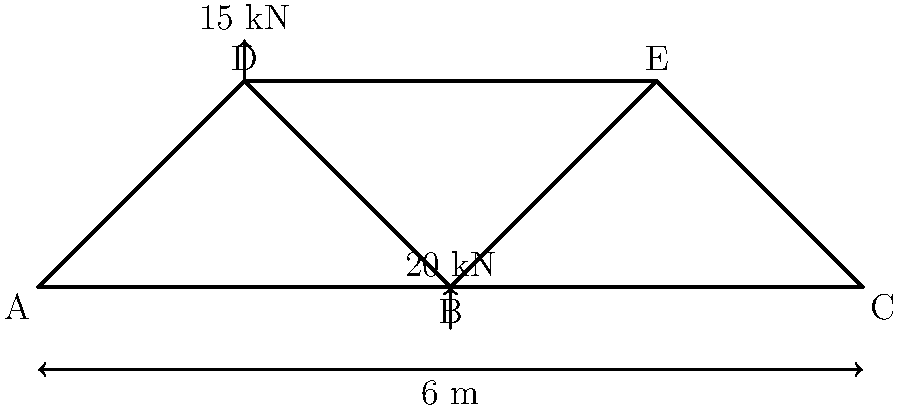As a civil engineer working on a project supported by Benjamin Kofi Ayeh, you are tasked with analyzing a truss bridge. The bridge has a span of 6 meters and a height of 1.5 meters. A vertical load of 20 kN is applied at point B, and a vertical load of 15 kN is applied at point D. Calculate the reaction forces at supports A and C, assuming the bridge is simply supported. Let's approach this step-by-step:

1) First, we need to understand that for a simply supported bridge, we have two reaction forces: one at point A (let's call it $R_A$) and one at point C (let's call it $R_C$).

2) We can use the principle of equilibrium to solve for these reactions. The sum of all forces and moments must equal zero.

3) Let's start with the sum of vertical forces:

   $$\sum F_y = R_A + R_C - 20 \text{ kN} - 15 \text{ kN} = 0$$

4) Now, let's consider the moments about point A (counterclockwise is positive):

   $$\sum M_A = R_C(6 \text{ m}) - 20 \text{ kN}(3 \text{ m}) - 15 \text{ kN}(1.5 \text{ m}) = 0$$

5) From the moment equation:

   $$R_C(6) = 20(3) + 15(1.5)$$
   $$R_C(6) = 60 + 22.5 = 82.5$$
   $$R_C = 82.5 / 6 = 13.75 \text{ kN}$$

6) Now we can substitute this back into the force equation:

   $$R_A + 13.75 \text{ kN} - 20 \text{ kN} - 15 \text{ kN} = 0$$
   $$R_A = 20 + 15 - 13.75 = 21.25 \text{ kN}$$

7) Therefore, the reaction forces are:
   $R_A = 21.25 \text{ kN}$ (upward)
   $R_C = 13.75 \text{ kN}$ (upward)
Answer: $R_A = 21.25 \text{ kN}$, $R_C = 13.75 \text{ kN}$ 